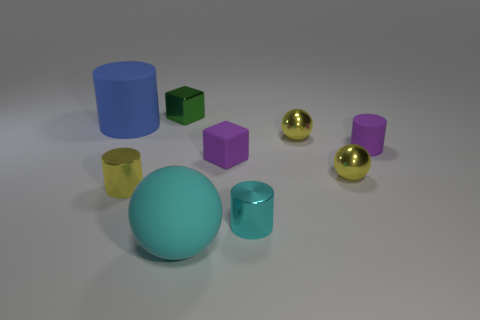What shape is the object that is the same color as the small rubber cylinder?
Your answer should be very brief. Cube. There is a green cube; what number of yellow shiny things are left of it?
Offer a terse response. 1. The yellow cylinder has what size?
Your response must be concise. Small. The sphere that is the same size as the blue cylinder is what color?
Your answer should be compact. Cyan. Are there any small shiny cylinders that have the same color as the big cylinder?
Keep it short and to the point. No. What material is the purple cube?
Give a very brief answer. Rubber. How many green metal objects are there?
Provide a short and direct response. 1. There is a matte cylinder on the right side of the tiny cyan object; does it have the same color as the shiny cylinder that is in front of the yellow metallic cylinder?
Your response must be concise. No. What is the size of the object that is the same color as the big matte sphere?
Your answer should be compact. Small. How many other objects are there of the same size as the rubber ball?
Ensure brevity in your answer.  1. 